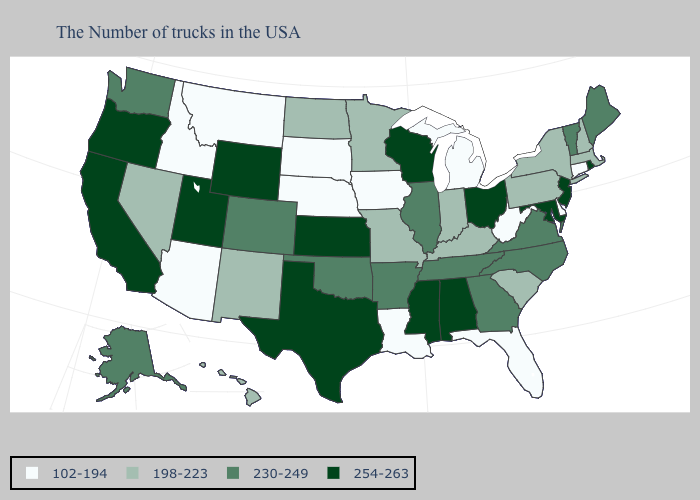Which states have the lowest value in the USA?
Concise answer only. Connecticut, Delaware, West Virginia, Florida, Michigan, Louisiana, Iowa, Nebraska, South Dakota, Montana, Arizona, Idaho. What is the highest value in the USA?
Keep it brief. 254-263. Which states hav the highest value in the West?
Be succinct. Wyoming, Utah, California, Oregon. Does Connecticut have the lowest value in the USA?
Answer briefly. Yes. What is the highest value in the MidWest ?
Keep it brief. 254-263. Does New Mexico have a higher value than New Jersey?
Quick response, please. No. Does Vermont have the highest value in the USA?
Write a very short answer. No. Name the states that have a value in the range 102-194?
Give a very brief answer. Connecticut, Delaware, West Virginia, Florida, Michigan, Louisiana, Iowa, Nebraska, South Dakota, Montana, Arizona, Idaho. Does Tennessee have a higher value than Mississippi?
Keep it brief. No. Name the states that have a value in the range 254-263?
Quick response, please. Rhode Island, New Jersey, Maryland, Ohio, Alabama, Wisconsin, Mississippi, Kansas, Texas, Wyoming, Utah, California, Oregon. Does Iowa have the lowest value in the MidWest?
Give a very brief answer. Yes. What is the highest value in states that border Illinois?
Write a very short answer. 254-263. Does Wyoming have the highest value in the USA?
Concise answer only. Yes. What is the value of Nevada?
Keep it brief. 198-223. What is the value of North Dakota?
Answer briefly. 198-223. 